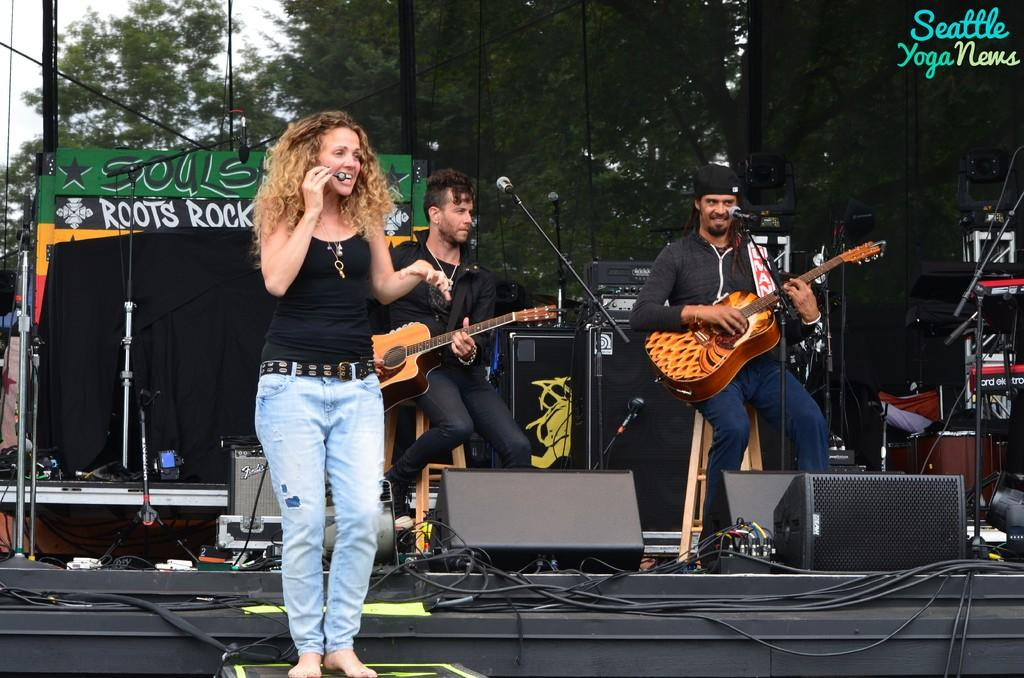How many people are in the image? There are three people in the image: two men and one woman. What are the men doing in the image? The men are sitting on stools and holding guitars. What is the woman doing in the image? The woman is standing. What can be seen in the background of the image? There are trees and microphones in the background of the image. How many clocks are hanging on the wall behind the men in the image? There are no clocks visible in the image. What is the role of the manager in the image? There is no manager present in the image. 